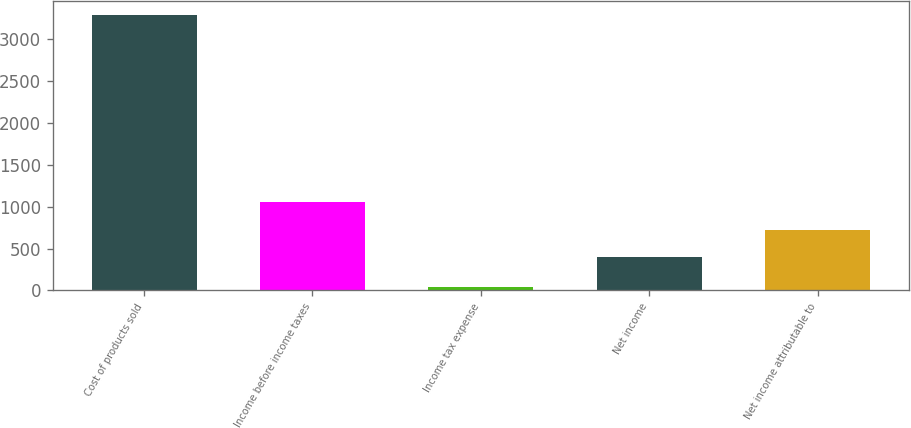<chart> <loc_0><loc_0><loc_500><loc_500><bar_chart><fcel>Cost of products sold<fcel>Income before income taxes<fcel>Income tax expense<fcel>Net income<fcel>Net income attributable to<nl><fcel>3294<fcel>1052.2<fcel>38<fcel>401<fcel>726.6<nl></chart> 